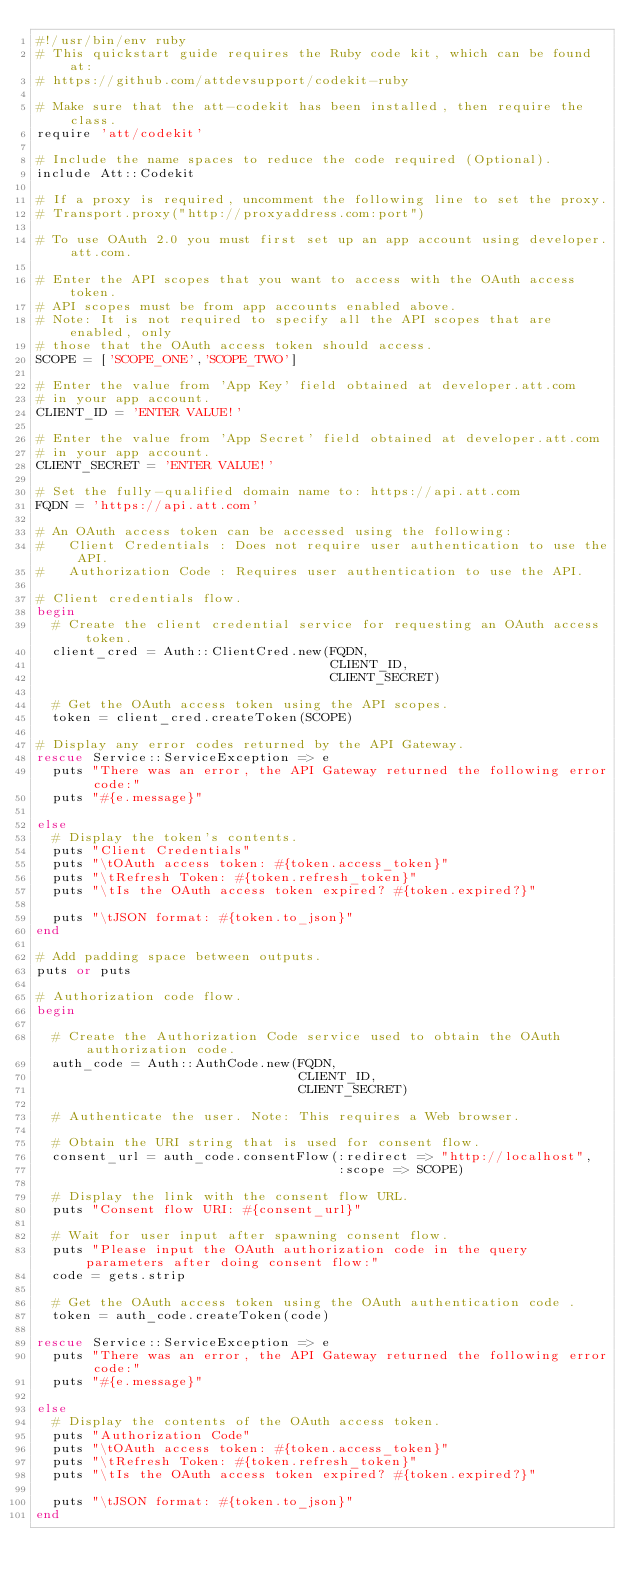<code> <loc_0><loc_0><loc_500><loc_500><_Ruby_>#!/usr/bin/env ruby
# This quickstart guide requires the Ruby code kit, which can be found at:
# https://github.com/attdevsupport/codekit-ruby

# Make sure that the att-codekit has been installed, then require the class.
require 'att/codekit'

# Include the name spaces to reduce the code required (Optional).
include Att::Codekit

# If a proxy is required, uncomment the following line to set the proxy.
# Transport.proxy("http://proxyaddress.com:port")

# To use OAuth 2.0 you must first set up an app account using developer.att.com.

# Enter the API scopes that you want to access with the OAuth access token. 
# API scopes must be from app accounts enabled above. 
# Note: It is not required to specify all the API scopes that are enabled, only 
# those that the OAuth access token should access.
SCOPE = ['SCOPE_ONE','SCOPE_TWO']

# Enter the value from 'App Key' field obtained at developer.att.com 
# in your app account.
CLIENT_ID = 'ENTER VALUE!'

# Enter the value from 'App Secret' field obtained at developer.att.com 
# in your app account.
CLIENT_SECRET = 'ENTER VALUE!'

# Set the fully-qualified domain name to: https://api.att.com
FQDN = 'https://api.att.com'

# An OAuth access token can be accessed using the following:
#   Client Credentials : Does not require user authentication to use the API.
#   Authorization Code : Requires user authentication to use the API.

# Client credentials flow.
begin 
  # Create the client credential service for requesting an OAuth access token.
  client_cred = Auth::ClientCred.new(FQDN, 
                                     CLIENT_ID,
                                     CLIENT_SECRET)

  # Get the OAuth access token using the API scopes.
  token = client_cred.createToken(SCOPE)

# Display any error codes returned by the API Gateway.
rescue Service::ServiceException => e
  puts "There was an error, the API Gateway returned the following error code:"
  puts "#{e.message}"

else
  # Display the token's contents.
  puts "Client Credentials"
  puts "\tOAuth access token: #{token.access_token}"
  puts "\tRefresh Token: #{token.refresh_token}"
  puts "\tIs the OAuth access token expired? #{token.expired?}"

  puts "\tJSON format: #{token.to_json}"
end

# Add padding space between outputs.
puts or puts 

# Authorization code flow.
begin 

  # Create the Authorization Code service used to obtain the OAuth authorization code.
  auth_code = Auth::AuthCode.new(FQDN,
                                 CLIENT_ID,
                                 CLIENT_SECRET)

  # Authenticate the user. Note: This requires a Web browser.

  # Obtain the URI string that is used for consent flow.
  consent_url = auth_code.consentFlow(:redirect => "http://localhost",
                                      :scope => SCOPE)

  # Display the link with the consent flow URL. 
  puts "Consent flow URI: #{consent_url}"

  # Wait for user input after spawning consent flow.
  puts "Please input the OAuth authorization code in the query parameters after doing consent flow:"
  code = gets.strip

  # Get the OAuth access token using the OAuth authentication code .
  token = auth_code.createToken(code)

rescue Service::ServiceException => e
  puts "There was an error, the API Gateway returned the following error code:"
  puts "#{e.message}"

else
  # Display the contents of the OAuth access token.
  puts "Authorization Code"
  puts "\tOAuth access token: #{token.access_token}"
  puts "\tRefresh Token: #{token.refresh_token}"
  puts "\tIs the OAuth access token expired? #{token.expired?}"

  puts "\tJSON format: #{token.to_json}"
end
</code> 